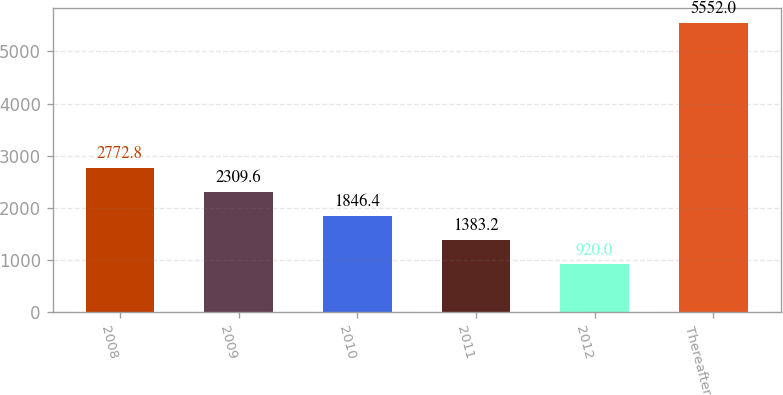Convert chart. <chart><loc_0><loc_0><loc_500><loc_500><bar_chart><fcel>2008<fcel>2009<fcel>2010<fcel>2011<fcel>2012<fcel>Thereafter<nl><fcel>2772.8<fcel>2309.6<fcel>1846.4<fcel>1383.2<fcel>920<fcel>5552<nl></chart> 